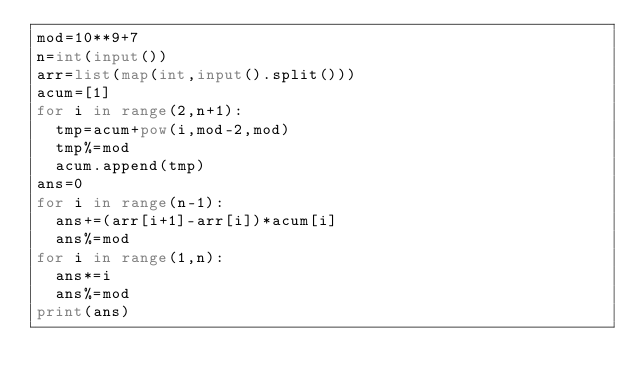<code> <loc_0><loc_0><loc_500><loc_500><_Python_>mod=10**9+7
n=int(input())
arr=list(map(int,input().split()))
acum=[1]
for i in range(2,n+1):
  tmp=acum+pow(i,mod-2,mod)
  tmp%=mod
  acum.append(tmp)
ans=0
for i in range(n-1):
  ans+=(arr[i+1]-arr[i])*acum[i]
  ans%=mod
for i in range(1,n):
  ans*=i
  ans%=mod
print(ans)</code> 